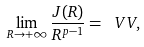<formula> <loc_0><loc_0><loc_500><loc_500>\lim _ { R \to + \infty } \frac { J ( R ) } { R ^ { p - 1 } } = \ V V ,</formula> 